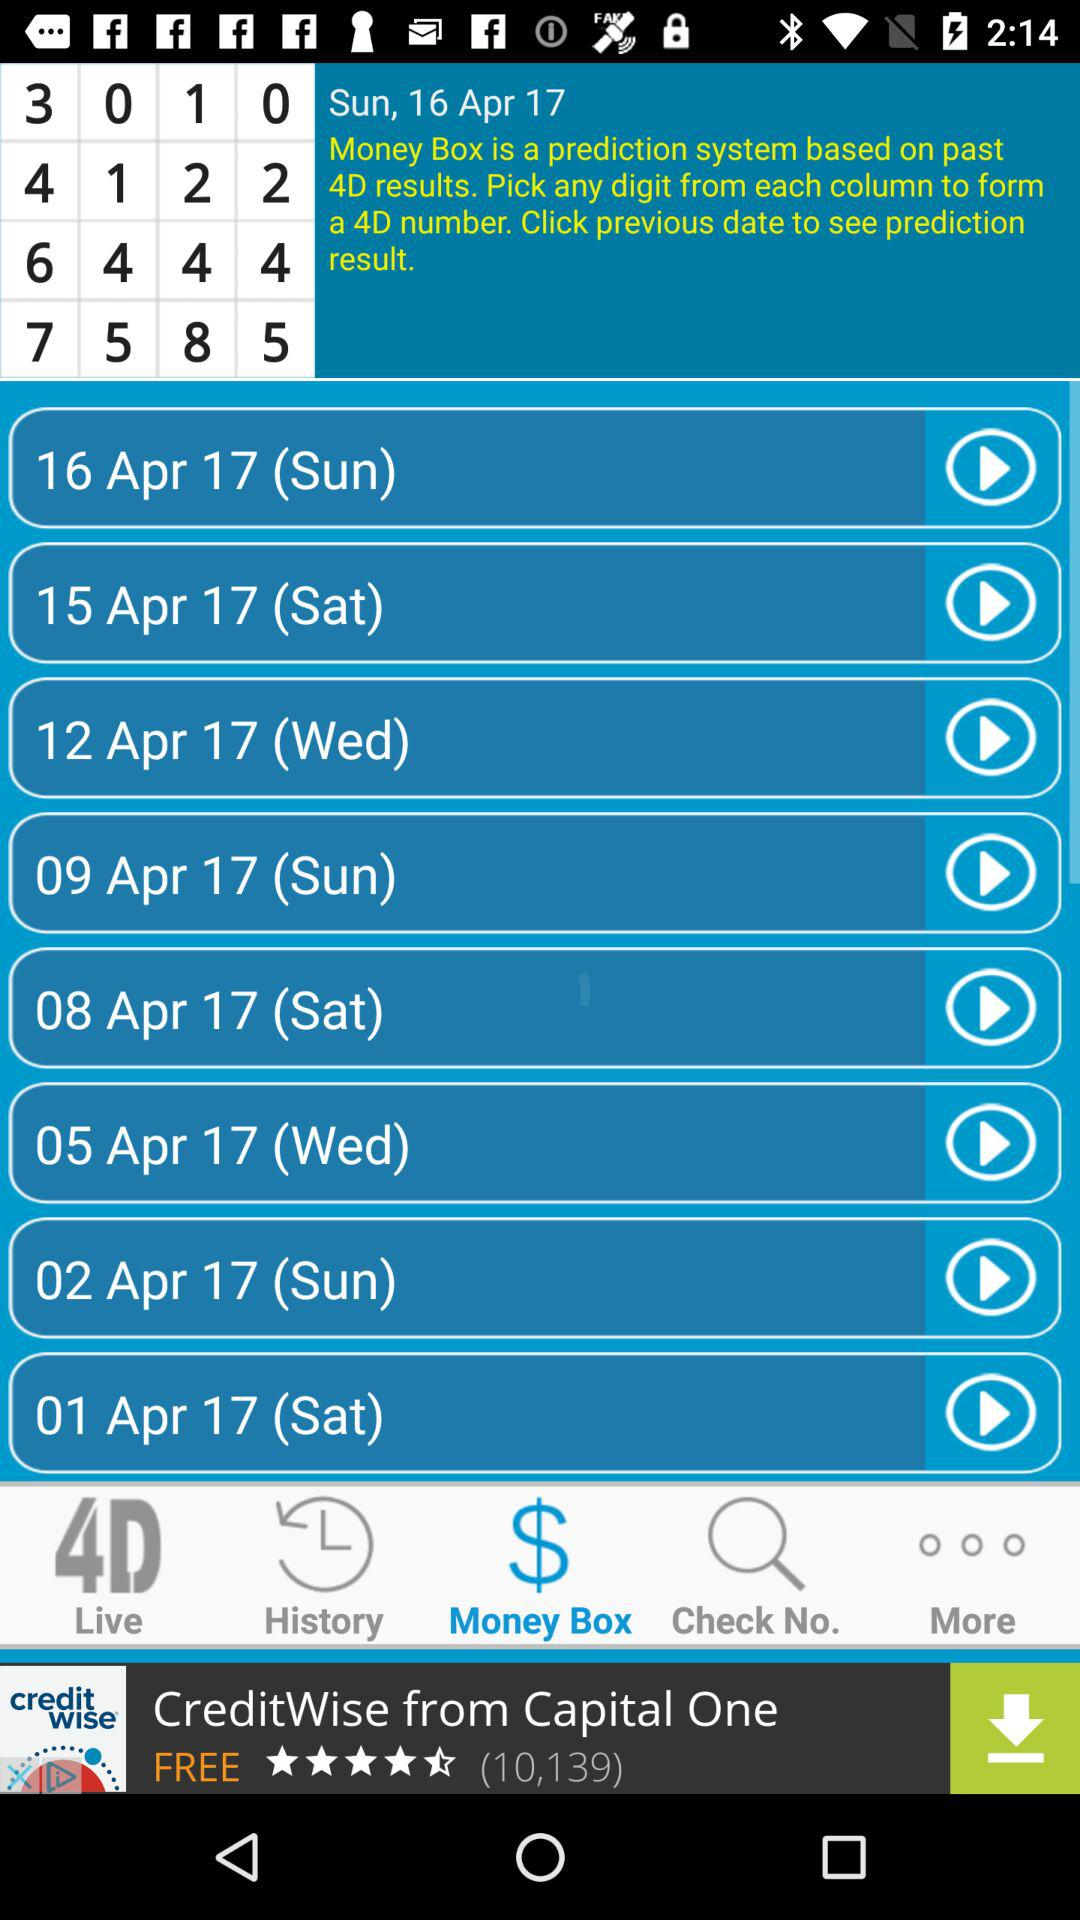What day is it on April 1? The day is Saturday. 